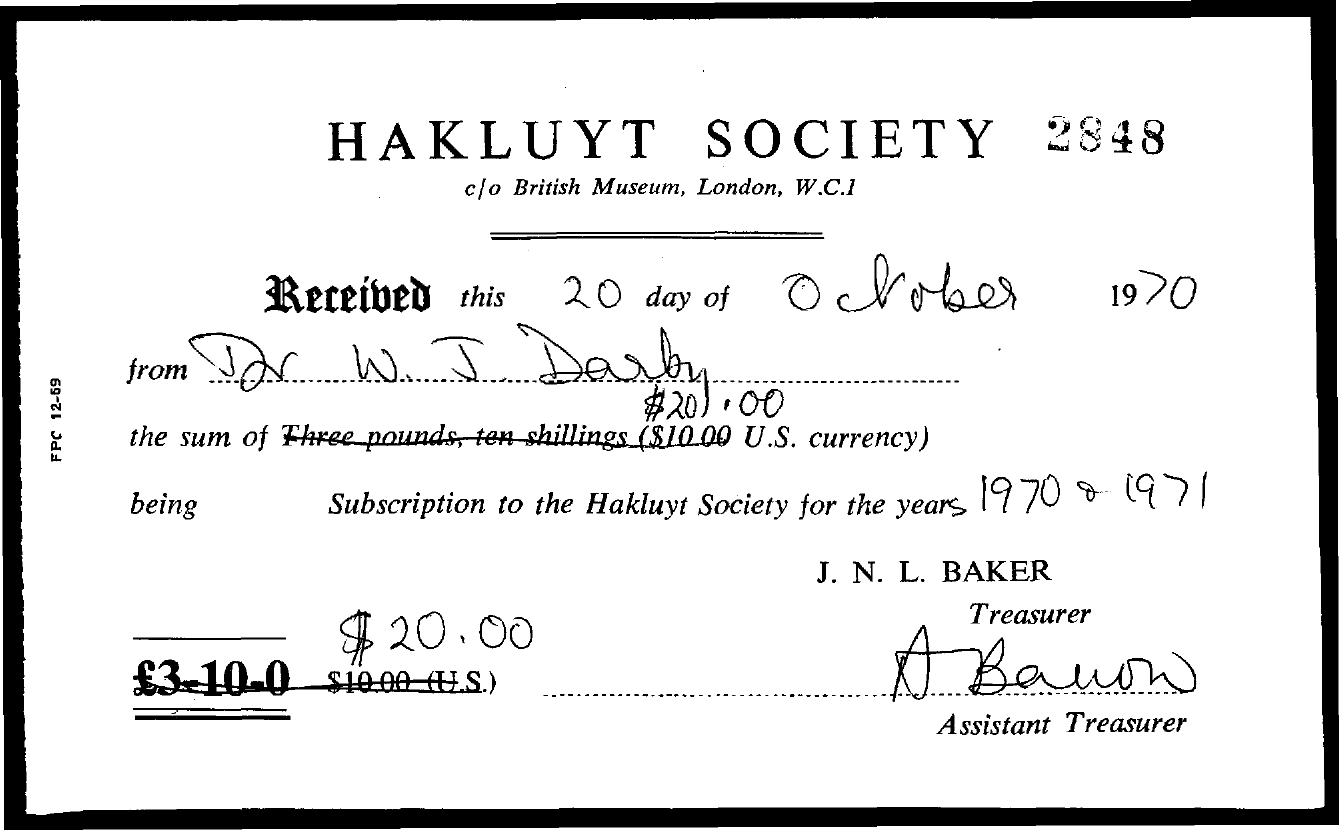Point out several critical features in this image. The number at the top right of the document is 2848. The title of the document is HAKLUYT SOCIETY... The treasurer's name is J. N. L. Baker. 